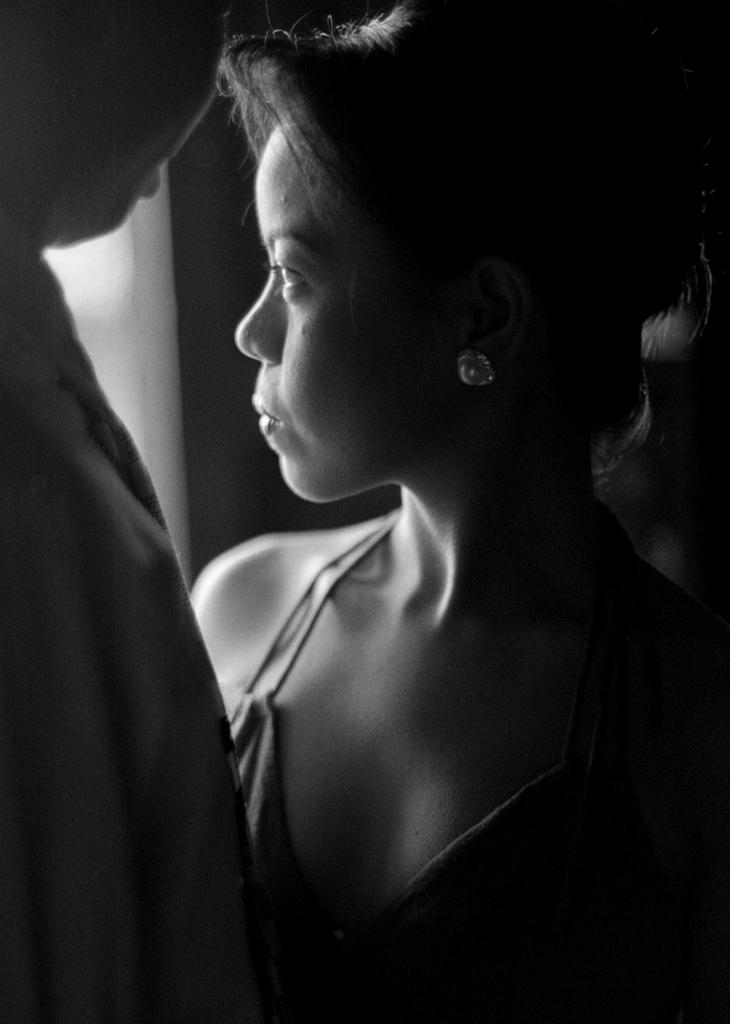What is the color scheme of the image? The image is black and white. What people can be seen in the image? There is a woman and a man in the image. What are the man and woman doing in the image? The man and woman are standing. What type of coal is being used by the lawyer in the image? There is no coal or lawyer present in the image. Is the man in the image taking a bath in the tub? There is: There is no tub present in the image, and the man is standing, not taking a bath. 